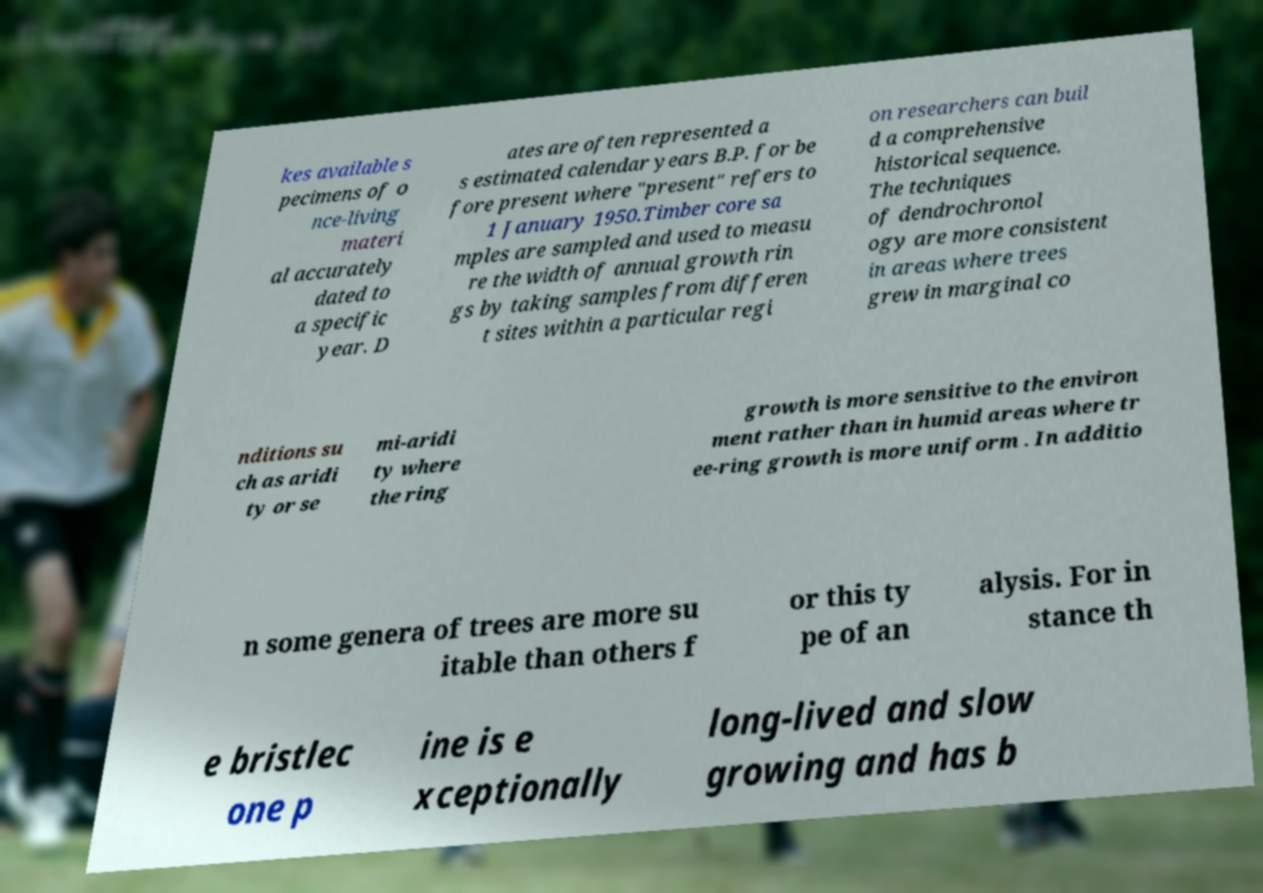For documentation purposes, I need the text within this image transcribed. Could you provide that? kes available s pecimens of o nce-living materi al accurately dated to a specific year. D ates are often represented a s estimated calendar years B.P. for be fore present where "present" refers to 1 January 1950.Timber core sa mples are sampled and used to measu re the width of annual growth rin gs by taking samples from differen t sites within a particular regi on researchers can buil d a comprehensive historical sequence. The techniques of dendrochronol ogy are more consistent in areas where trees grew in marginal co nditions su ch as aridi ty or se mi-aridi ty where the ring growth is more sensitive to the environ ment rather than in humid areas where tr ee-ring growth is more uniform . In additio n some genera of trees are more su itable than others f or this ty pe of an alysis. For in stance th e bristlec one p ine is e xceptionally long-lived and slow growing and has b 